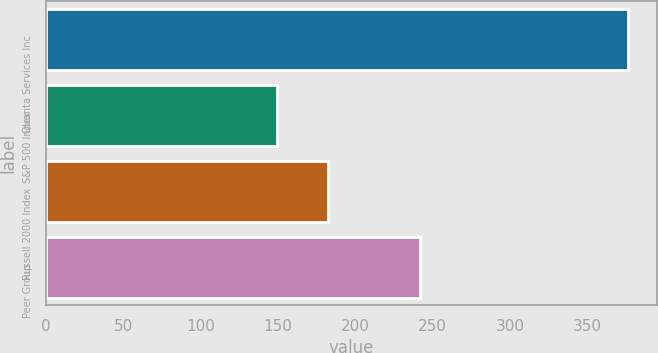<chart> <loc_0><loc_0><loc_500><loc_500><bar_chart><fcel>Quanta Services Inc<fcel>S&P 500 Index<fcel>Russell 2000 Index<fcel>Peer Group<nl><fcel>376.29<fcel>149.7<fcel>182.18<fcel>242.08<nl></chart> 